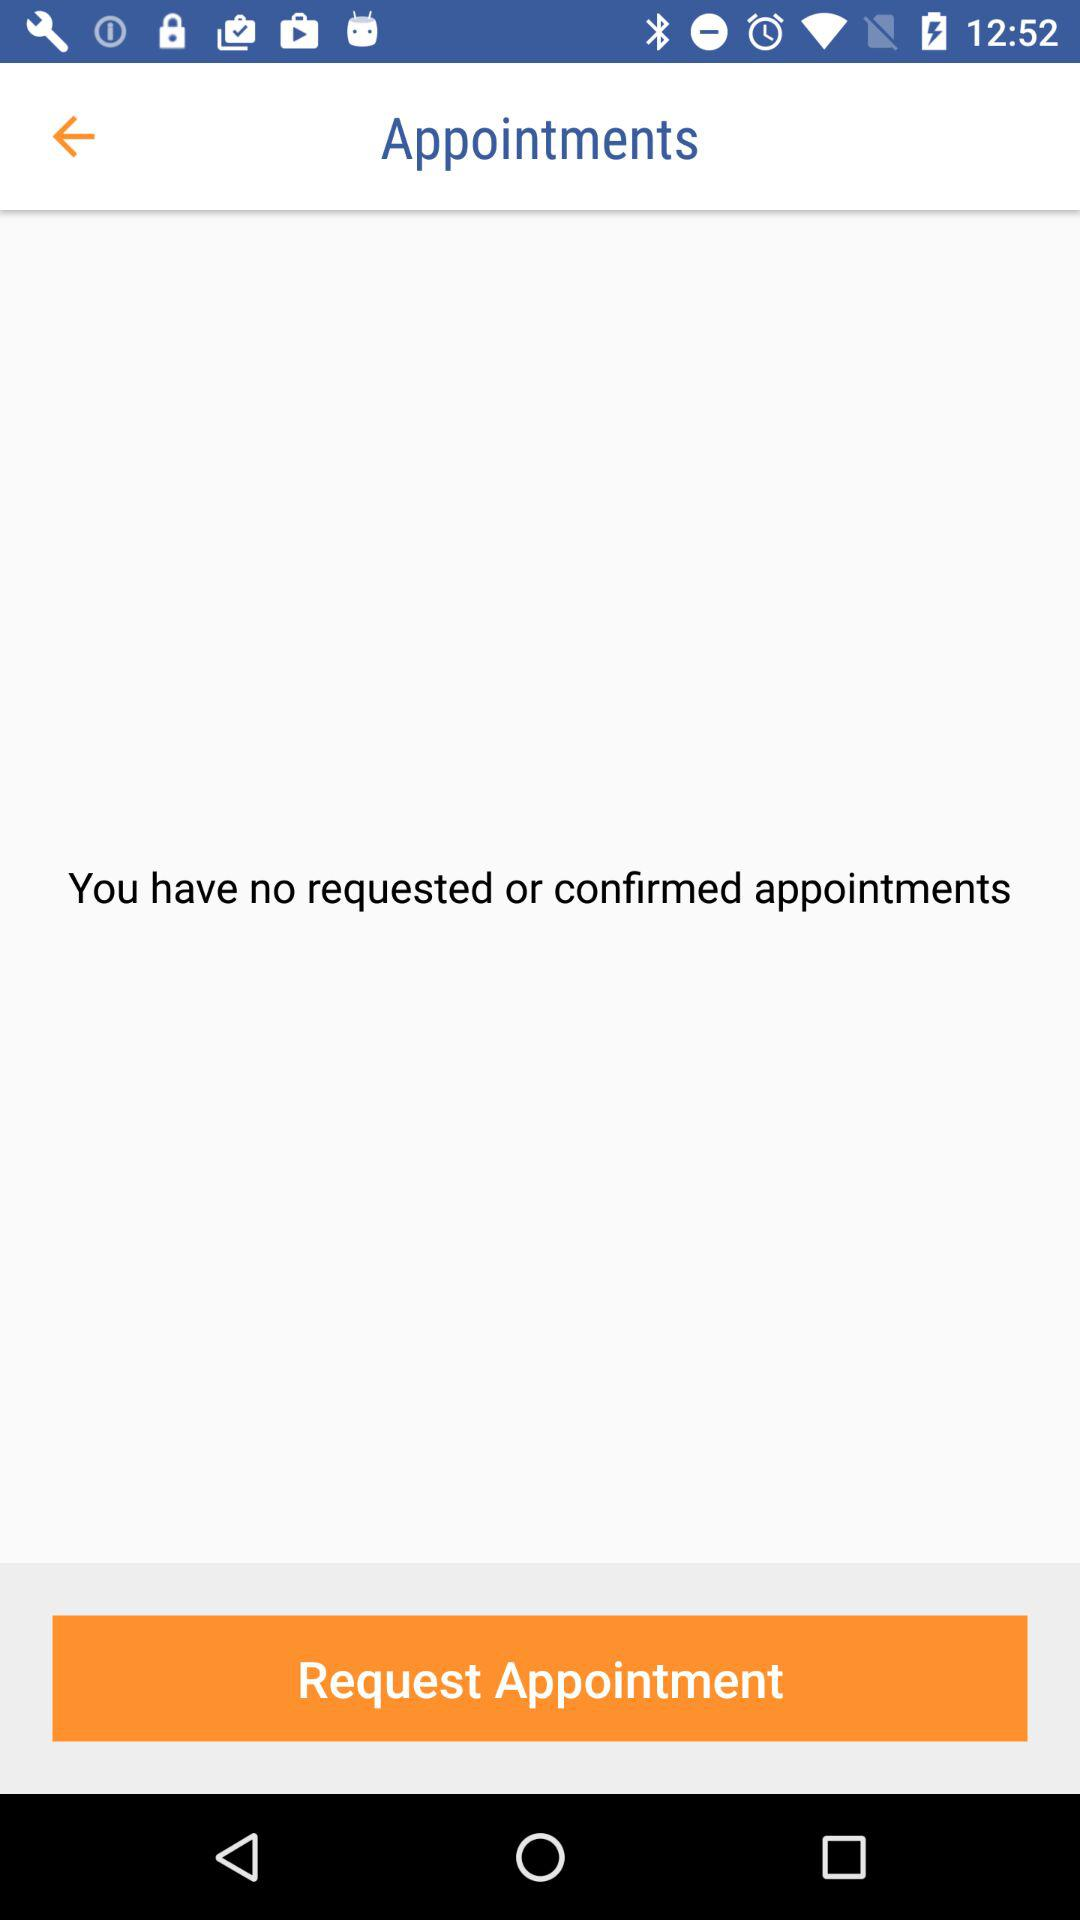How many appointments do I have?
Answer the question using a single word or phrase. 0 